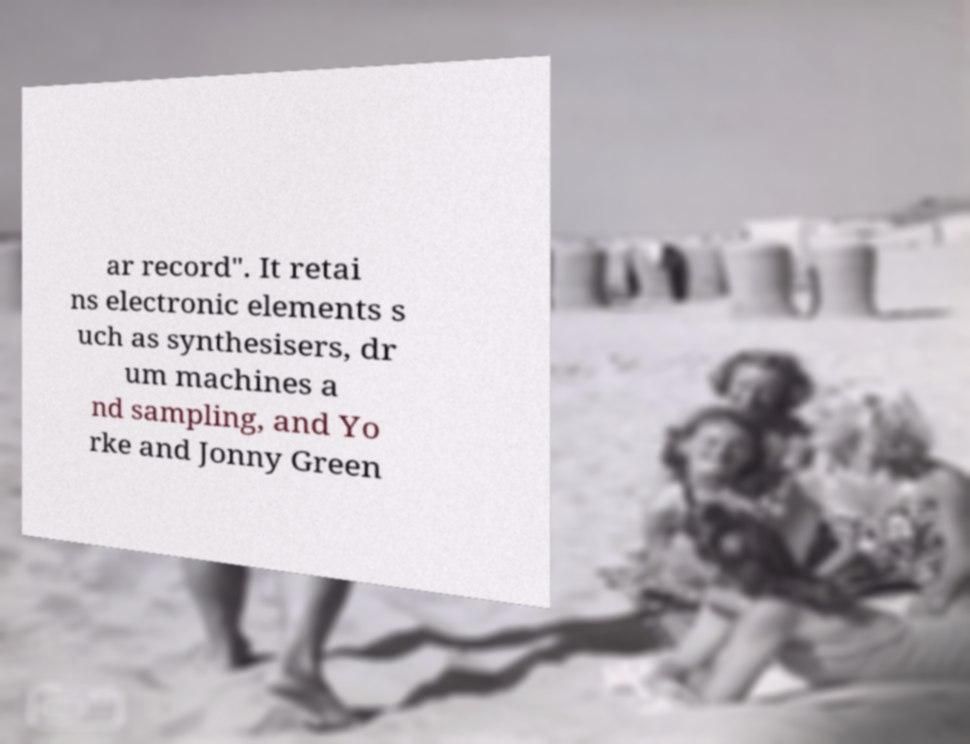Please identify and transcribe the text found in this image. ar record". It retai ns electronic elements s uch as synthesisers, dr um machines a nd sampling, and Yo rke and Jonny Green 